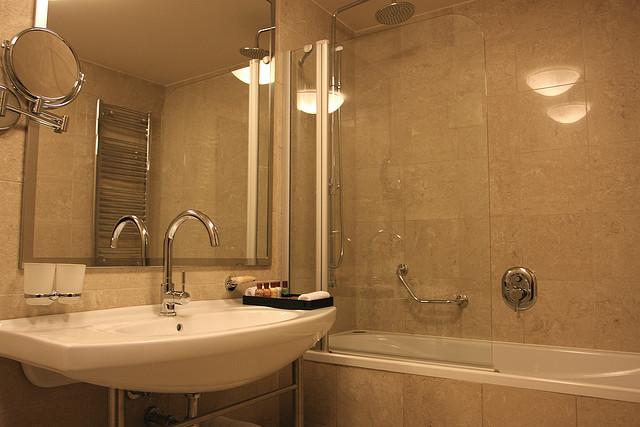Is this bathroom nice?
Write a very short answer. Yes. Is this bathroom in a hotel?
Write a very short answer. Yes. What is on the tray?
Quick response, please. Toiletries. How many mirror are in this picture?
Quick response, please. 2. What is on the shelf?
Concise answer only. Soap. 